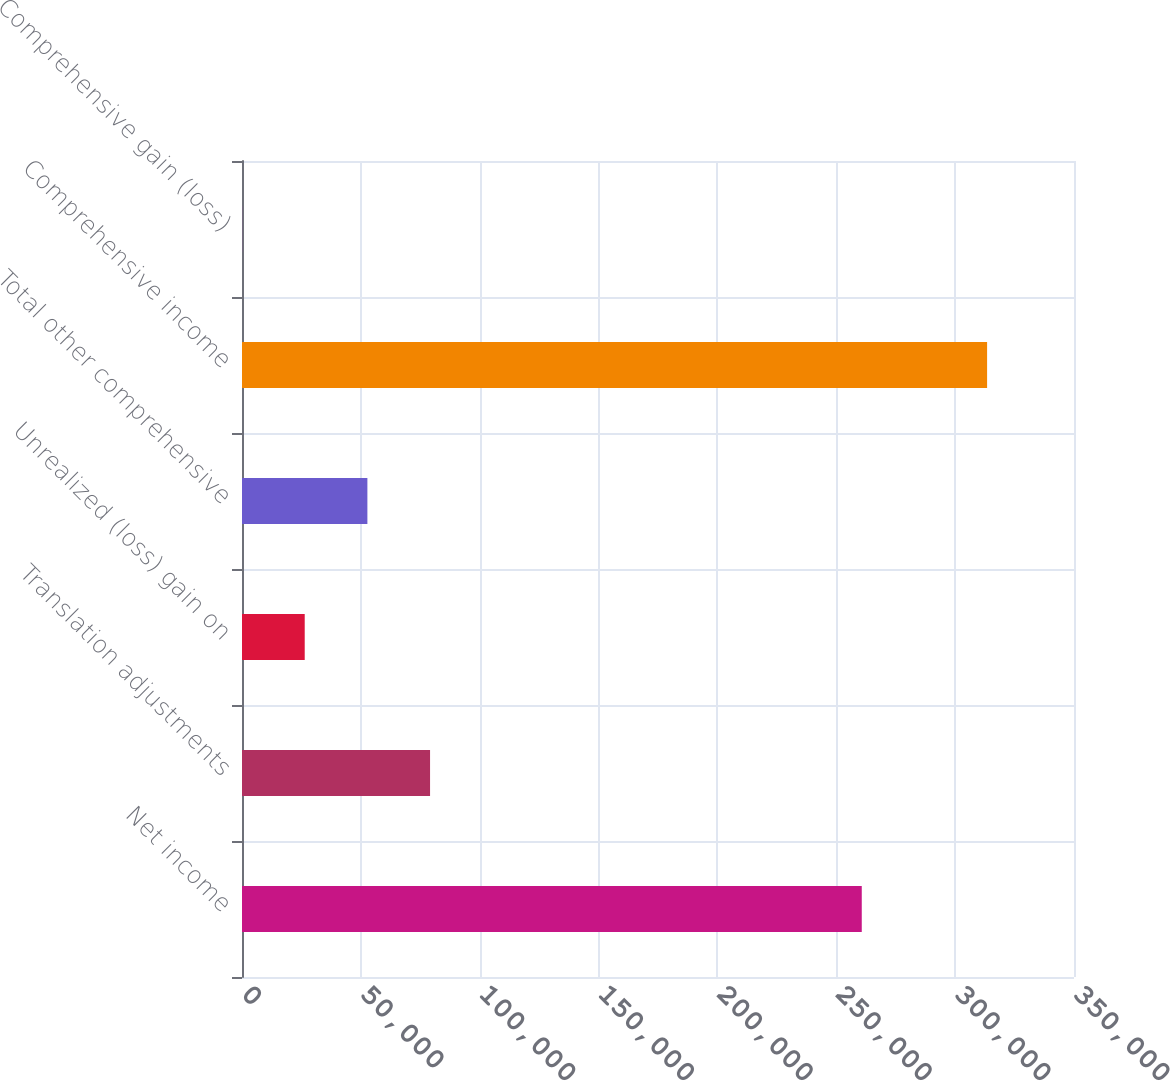<chart> <loc_0><loc_0><loc_500><loc_500><bar_chart><fcel>Net income<fcel>Translation adjustments<fcel>Unrealized (loss) gain on<fcel>Total other comprehensive<fcel>Comprehensive income<fcel>Comprehensive gain (loss)<nl><fcel>260716<fcel>79110<fcel>26384<fcel>52747<fcel>313442<fcel>21<nl></chart> 